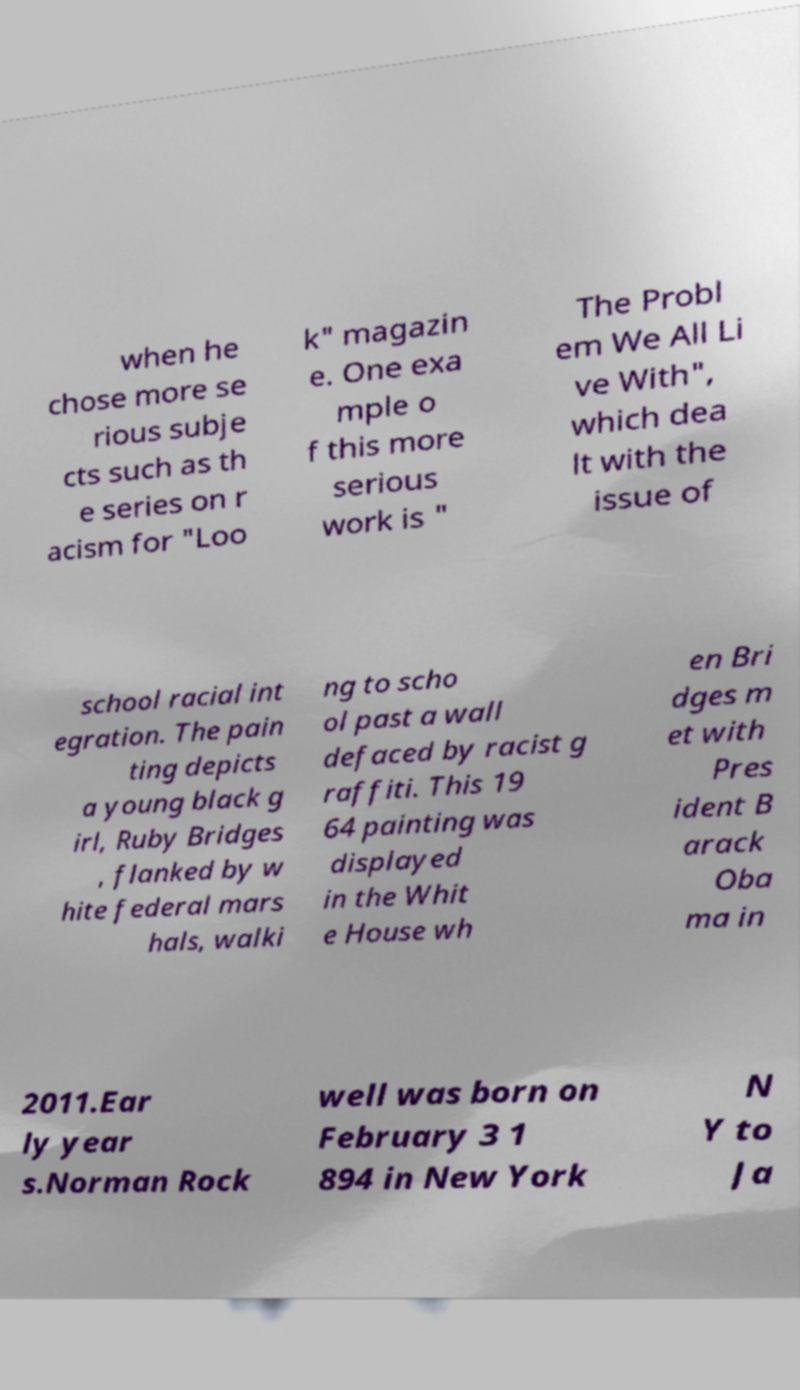I need the written content from this picture converted into text. Can you do that? when he chose more se rious subje cts such as th e series on r acism for "Loo k" magazin e. One exa mple o f this more serious work is " The Probl em We All Li ve With", which dea lt with the issue of school racial int egration. The pain ting depicts a young black g irl, Ruby Bridges , flanked by w hite federal mars hals, walki ng to scho ol past a wall defaced by racist g raffiti. This 19 64 painting was displayed in the Whit e House wh en Bri dges m et with Pres ident B arack Oba ma in 2011.Ear ly year s.Norman Rock well was born on February 3 1 894 in New York N Y to Ja 